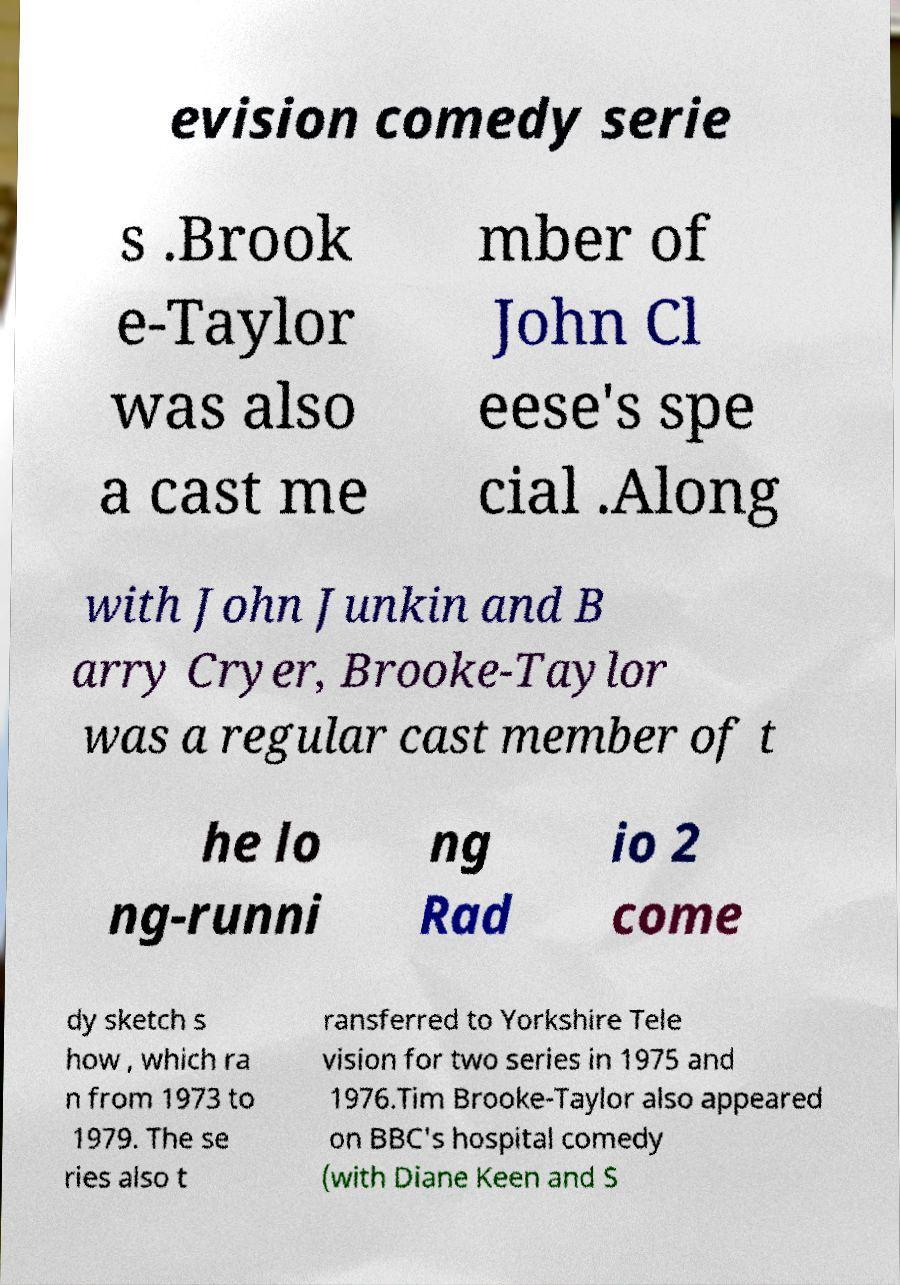What messages or text are displayed in this image? I need them in a readable, typed format. evision comedy serie s .Brook e-Taylor was also a cast me mber of John Cl eese's spe cial .Along with John Junkin and B arry Cryer, Brooke-Taylor was a regular cast member of t he lo ng-runni ng Rad io 2 come dy sketch s how , which ra n from 1973 to 1979. The se ries also t ransferred to Yorkshire Tele vision for two series in 1975 and 1976.Tim Brooke-Taylor also appeared on BBC's hospital comedy (with Diane Keen and S 